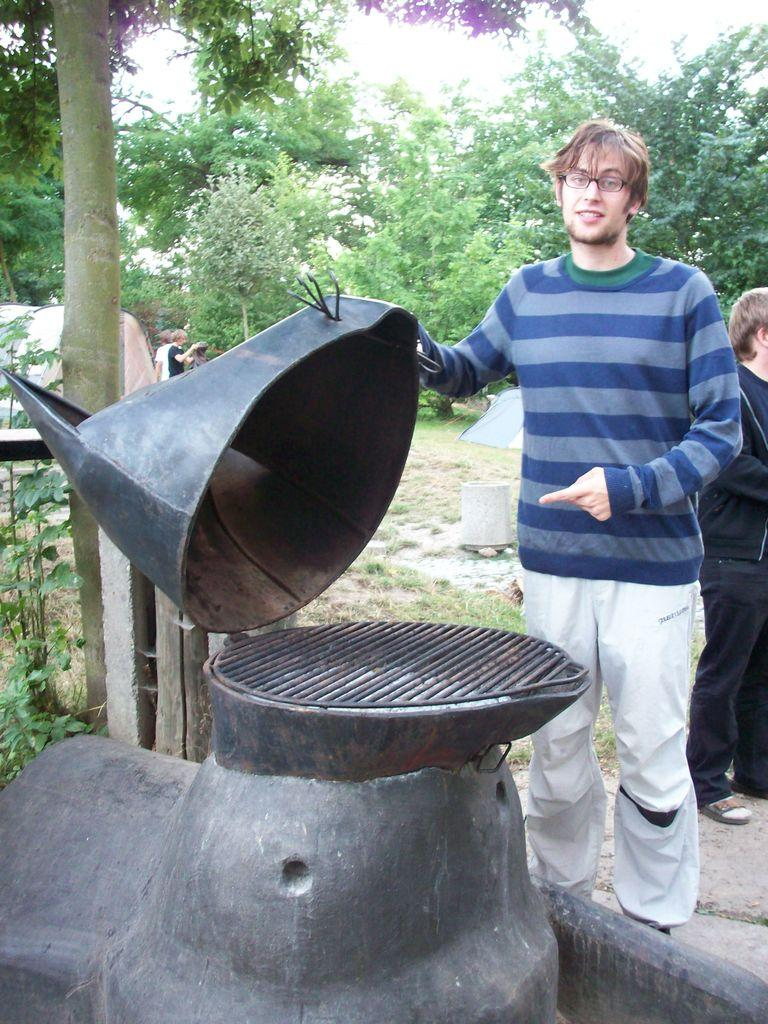What is the man in the image doing? The man is standing in the image. What is the man holding in the image? The man is holding an object. Can you describe the person behind the man? There is a person standing behind the man. What can be seen in the background of the image? There are trees visible in the background of the image. What is the caption of the image? There is no caption present in the image. How old is the man's daughter in the image? There is no daughter present in the image. 